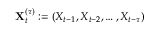Convert formula to latex. <formula><loc_0><loc_0><loc_500><loc_500>X _ { t } ^ { ( \tau ) } \colon = ( X _ { t - 1 } , X _ { t - 2 } , \dots , X _ { t - \tau } )</formula> 